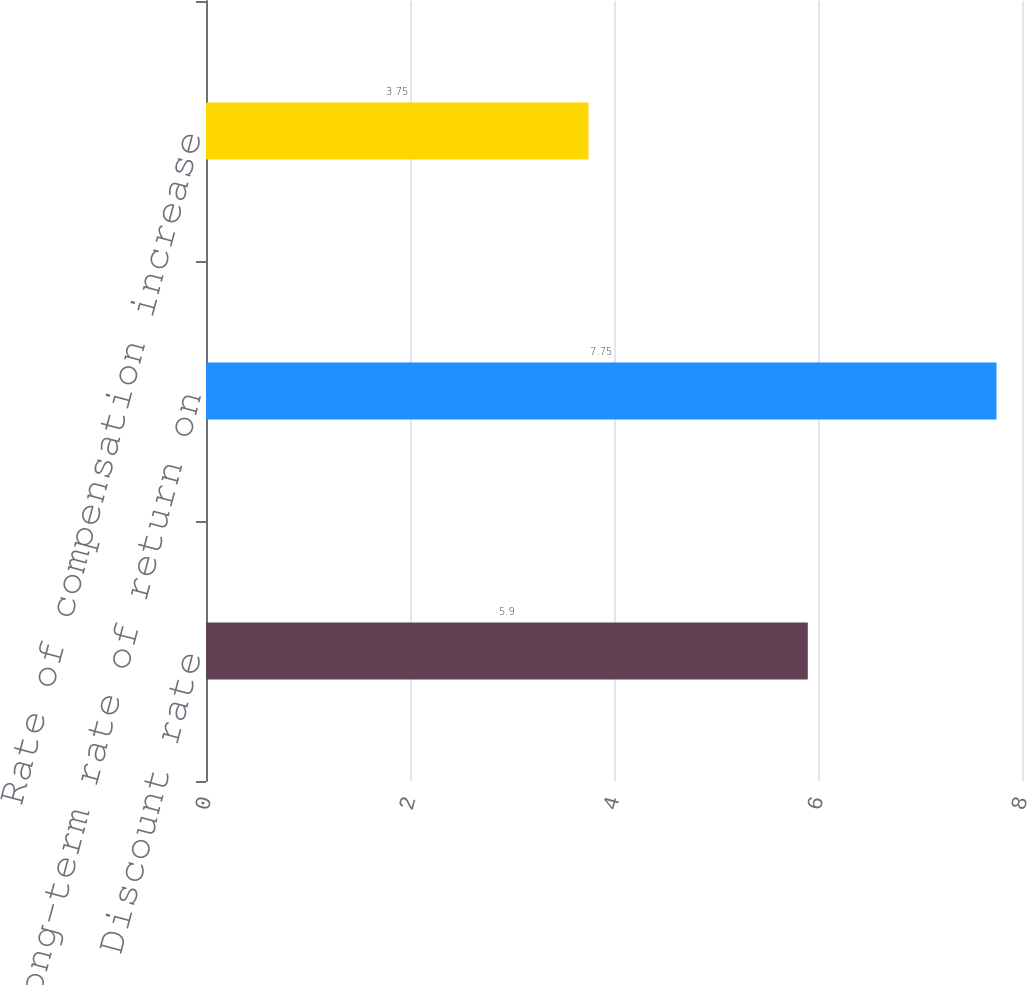Convert chart. <chart><loc_0><loc_0><loc_500><loc_500><bar_chart><fcel>Discount rate<fcel>Long-term rate of return on<fcel>Rate of compensation increase<nl><fcel>5.9<fcel>7.75<fcel>3.75<nl></chart> 